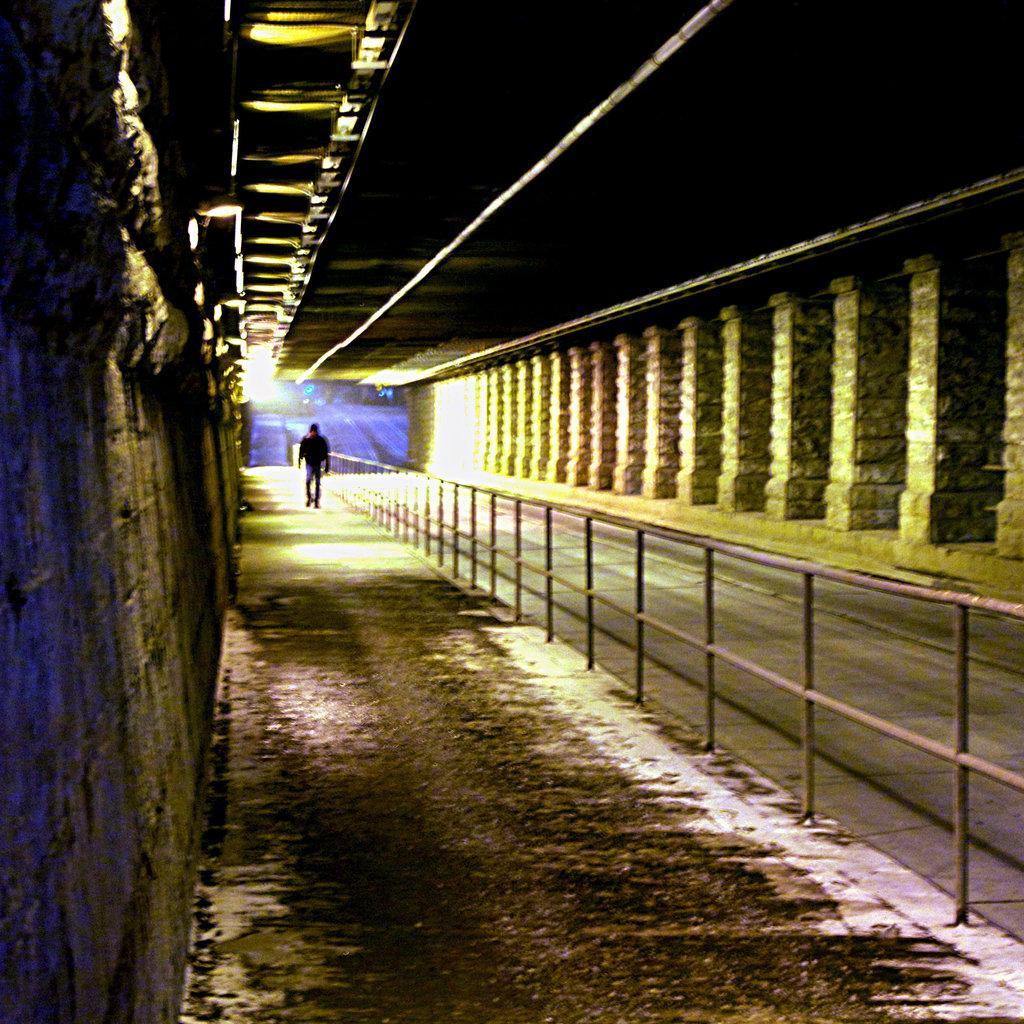Please provide a concise description of this image. This image is taken during night time. There is a person walking on the path. Beside the person there is a fence. On both sides of the image there is a constructed wall. At the top there is roof. 